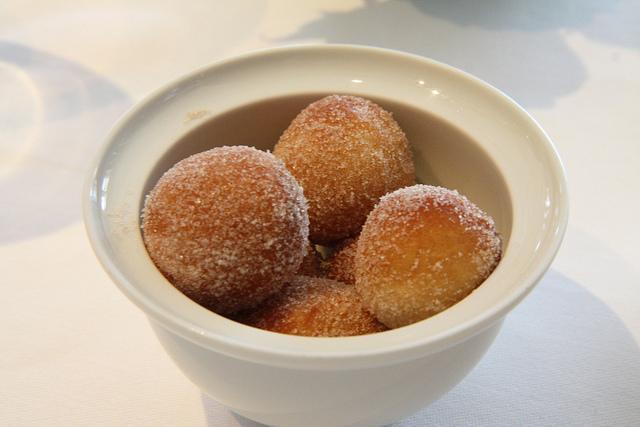How many donuts are visible?
Give a very brief answer. 5. How many feet does the person have in the air?
Give a very brief answer. 0. 